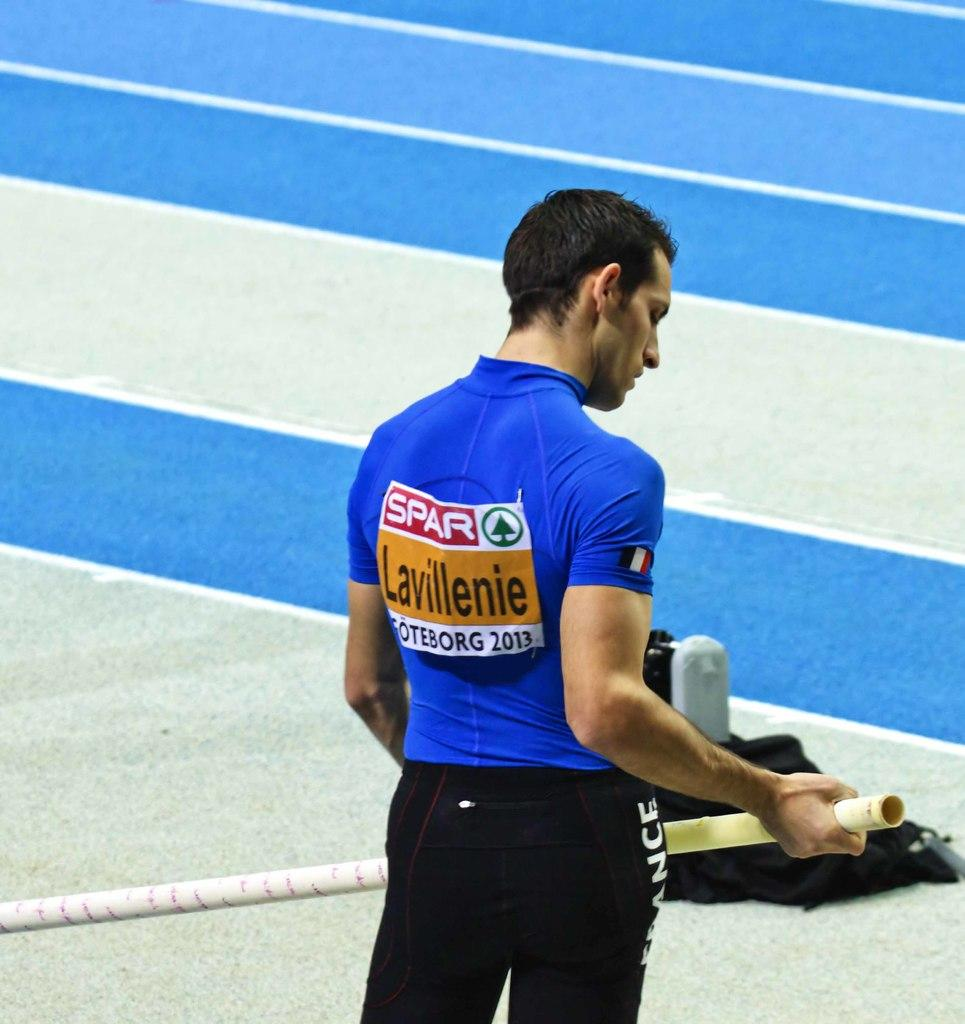<image>
Present a compact description of the photo's key features. A man in a blue shirt has the word Lavillenie on his back. 